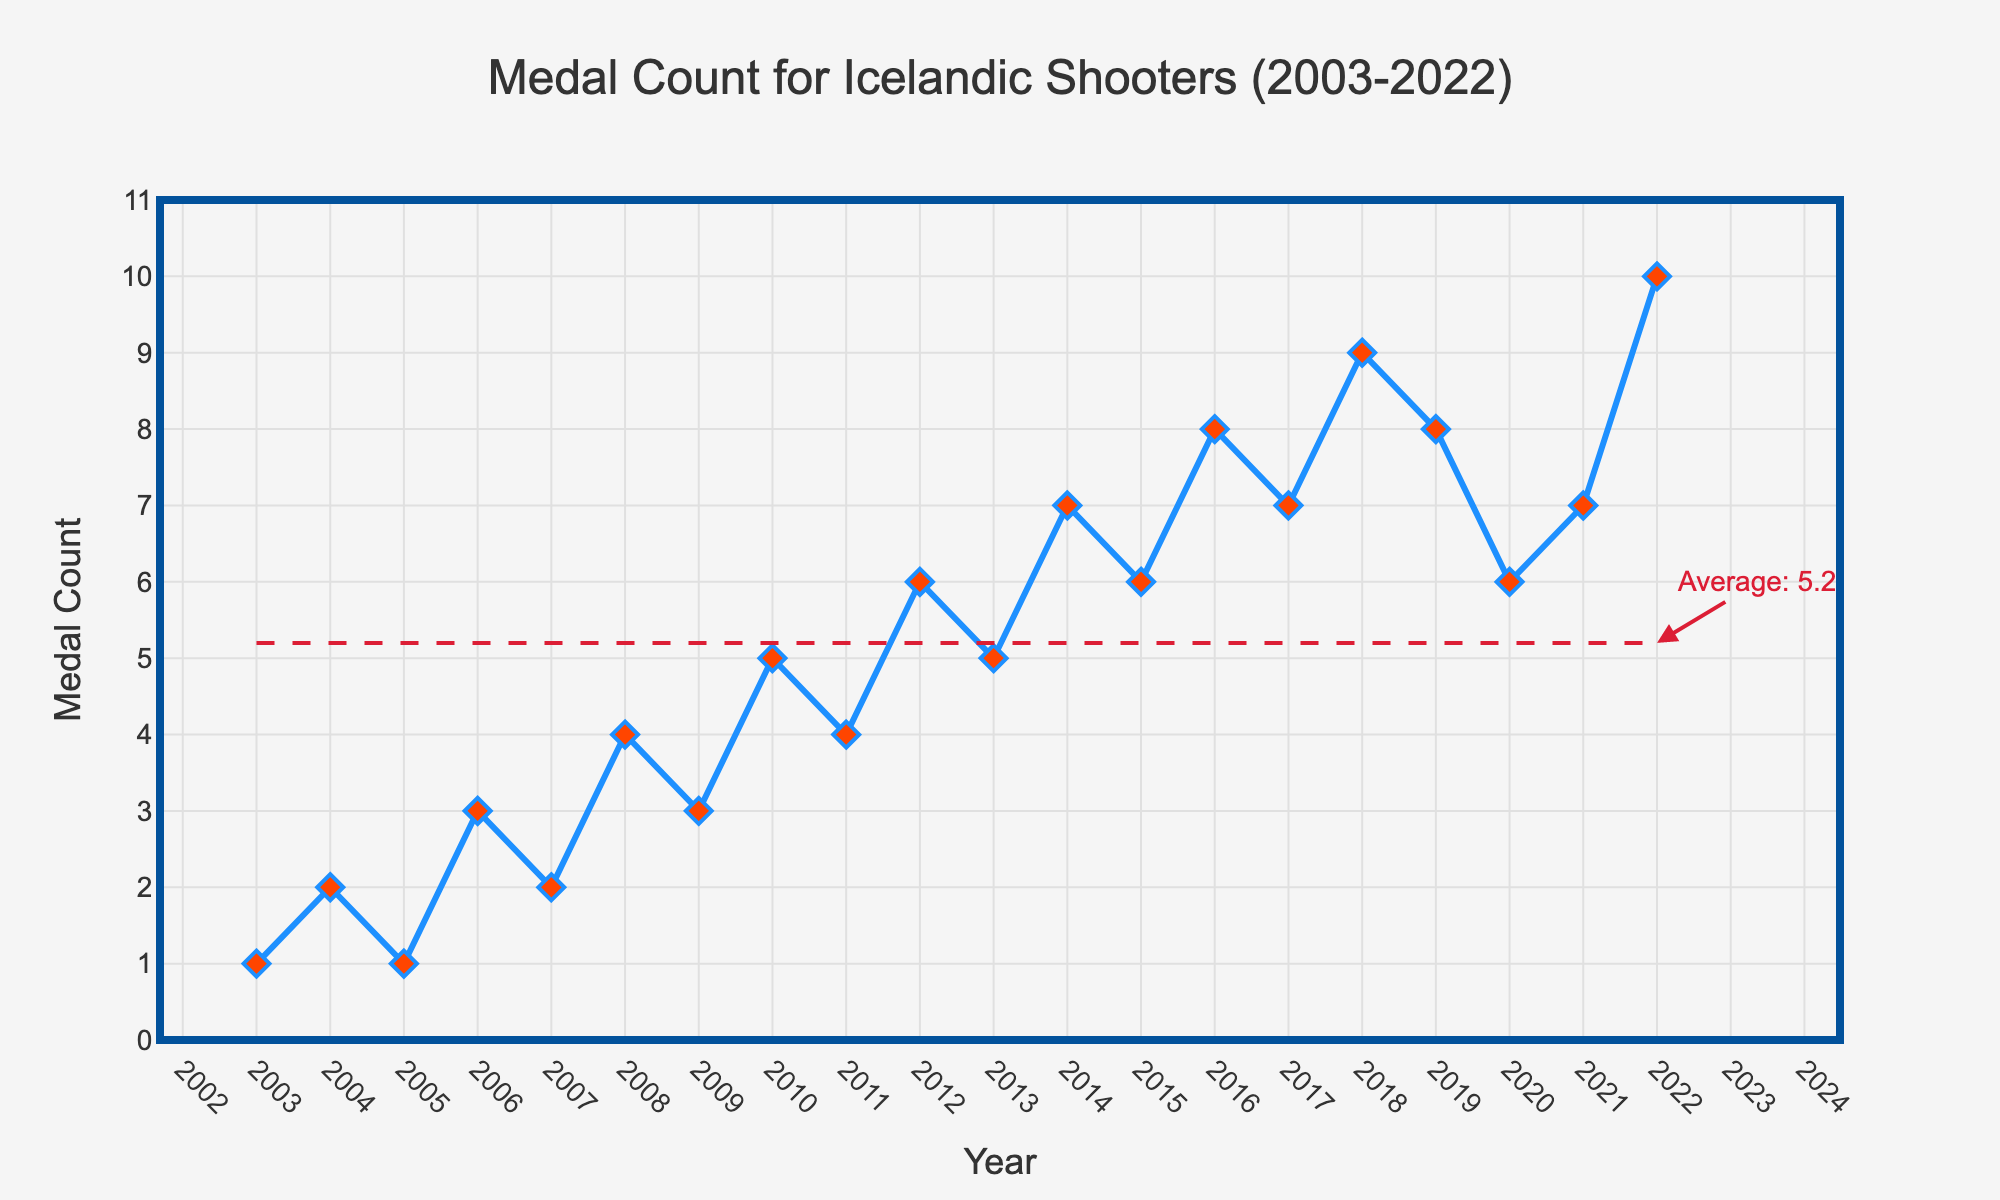What was the highest medal count for Icelandic shooters during the 20-year period? The highest point on the y-axis in the chart shows a peak value, which corresponds to the year 2022. The y-axis label at this point indicates the medal count.
Answer: 10 In which year did Icelandic shooters achieve the lowest medal count, and what was the count? The lowest point on the y-axis in the chart shows the minimum value, which corresponds to the year 2003. The y-axis label at this point indicates the medal count.
Answer: 2003, 1 How did the medal count change from 2010 to 2012? In 2010, the medal count was 5. In 2012, it increased to 6 medals. This is seen by tracking the line from 2010 to 2012, noticing an upward trend.
Answer: Increased by 1 What is the average medal count over the 20-year period? The chart includes a horizontal dashed line and an annotation indicating the average medal count. The annotation near the dashed line indicates the exact value.
Answer: 5.1 Which years had a medal count equal to the calculated average of 5.1? The plotted points the horizontal dashed line intersects help identify these years. The annotation does not show any intersections, confirming no exact years match.
Answer: None Between which consecutive years did the medal count increase the most? Observing the steepest upward slope in the chart shows between 2017 (7 medals) and 2018 (9 medals), indicating a 2 medal increase.
Answer: 2017 to 2018 Between which consecutive years did the medal count decrease the most? Observing the steepest downward slope in the chart identifies between 2019 (8 medals) and 2020 (6 medals), indicating a 2 medal decrease.
Answer: 2019 to 2020 How frequently did the medal count increase year over year during the 20-year period? By tracking each year’s count compared to the previous year's through the line chart, count the number of upward trends. There are 11 increases.
Answer: 11 times What is the difference in medal count between the first and last years in the chart? The first year, 2003, had 1 medal, and the last year, 2022, had 10 medals. The difference is calculated by subtracting the first count from the last: 10 - 1.
Answer: 9 